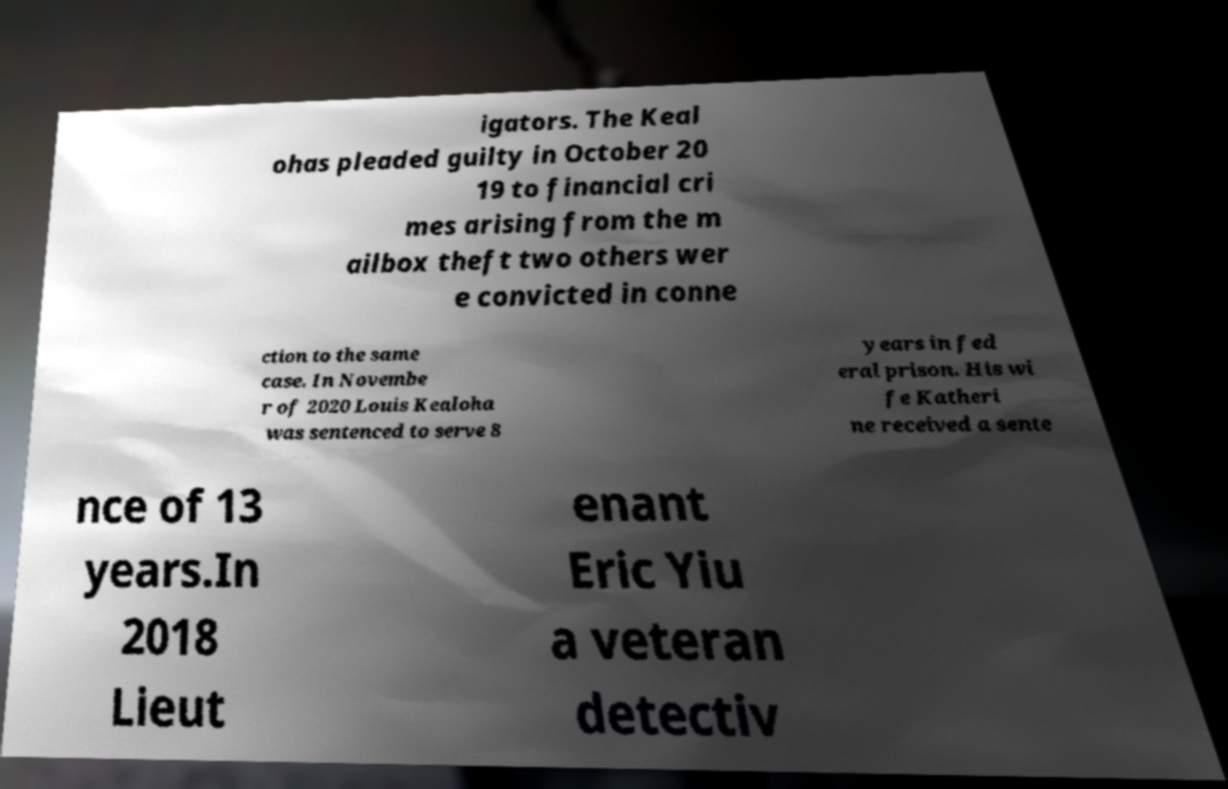Please read and relay the text visible in this image. What does it say? igators. The Keal ohas pleaded guilty in October 20 19 to financial cri mes arising from the m ailbox theft two others wer e convicted in conne ction to the same case. In Novembe r of 2020 Louis Kealoha was sentenced to serve 8 years in fed eral prison. His wi fe Katheri ne received a sente nce of 13 years.In 2018 Lieut enant Eric Yiu a veteran detectiv 